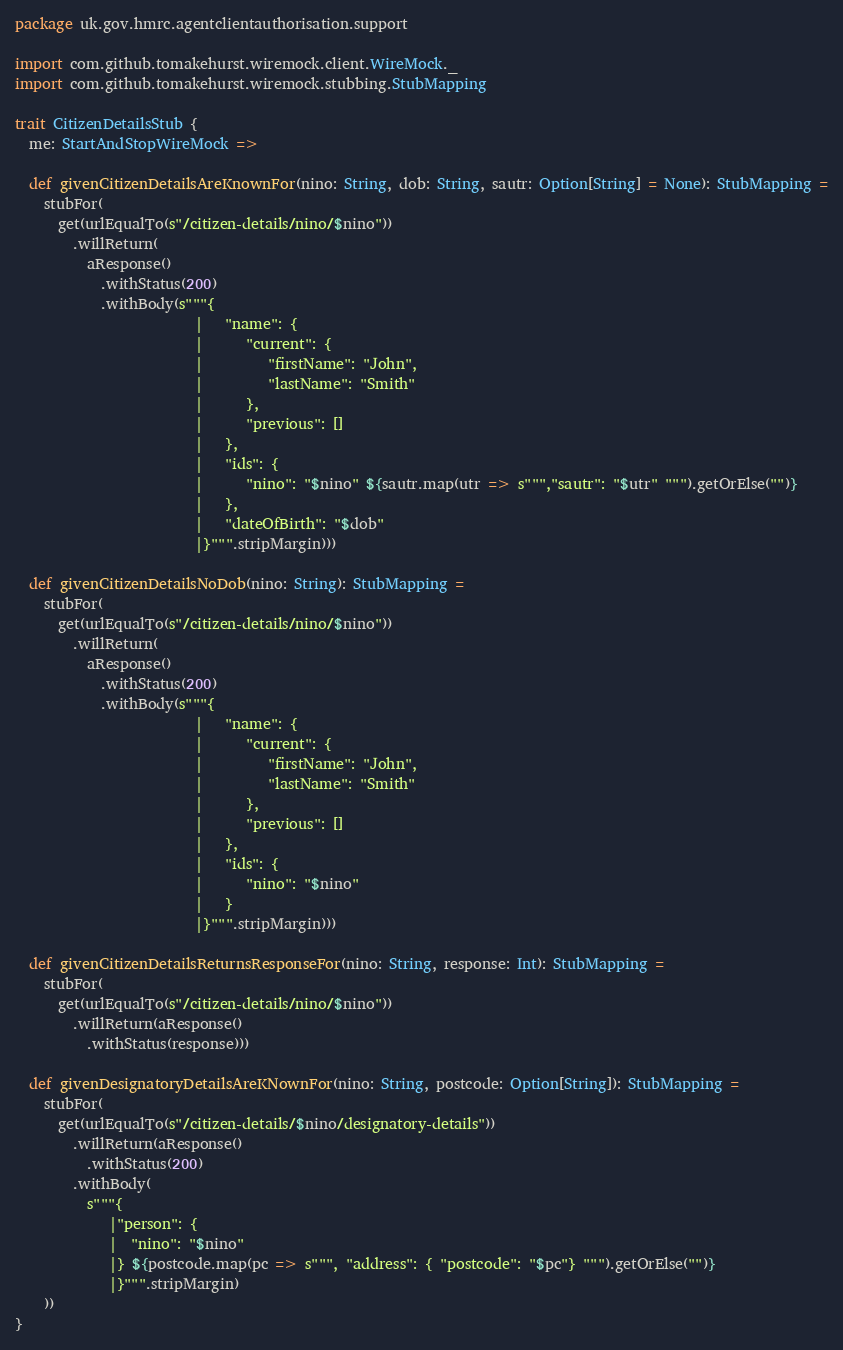<code> <loc_0><loc_0><loc_500><loc_500><_Scala_>package uk.gov.hmrc.agentclientauthorisation.support

import com.github.tomakehurst.wiremock.client.WireMock._
import com.github.tomakehurst.wiremock.stubbing.StubMapping

trait CitizenDetailsStub {
  me: StartAndStopWireMock =>

  def givenCitizenDetailsAreKnownFor(nino: String, dob: String, sautr: Option[String] = None): StubMapping =
    stubFor(
      get(urlEqualTo(s"/citizen-details/nino/$nino"))
        .willReturn(
          aResponse()
            .withStatus(200)
            .withBody(s"""{
                         |   "name": {
                         |      "current": {
                         |         "firstName": "John",
                         |         "lastName": "Smith"
                         |      },
                         |      "previous": []
                         |   },
                         |   "ids": {
                         |      "nino": "$nino" ${sautr.map(utr => s""","sautr": "$utr" """).getOrElse("")}
                         |   },
                         |   "dateOfBirth": "$dob"
                         |}""".stripMargin)))

  def givenCitizenDetailsNoDob(nino: String): StubMapping =
    stubFor(
      get(urlEqualTo(s"/citizen-details/nino/$nino"))
        .willReturn(
          aResponse()
            .withStatus(200)
            .withBody(s"""{
                         |   "name": {
                         |      "current": {
                         |         "firstName": "John",
                         |         "lastName": "Smith"
                         |      },
                         |      "previous": []
                         |   },
                         |   "ids": {
                         |      "nino": "$nino"
                         |   }
                         |}""".stripMargin)))

  def givenCitizenDetailsReturnsResponseFor(nino: String, response: Int): StubMapping =
    stubFor(
      get(urlEqualTo(s"/citizen-details/nino/$nino"))
        .willReturn(aResponse()
          .withStatus(response)))

  def givenDesignatoryDetailsAreKNownFor(nino: String, postcode: Option[String]): StubMapping =
    stubFor(
      get(urlEqualTo(s"/citizen-details/$nino/designatory-details"))
        .willReturn(aResponse()
          .withStatus(200)
        .withBody(
          s"""{
             |"person": {
             |  "nino": "$nino"
             |} ${postcode.map(pc => s""", "address": { "postcode": "$pc"} """).getOrElse("")}
             |}""".stripMargin)
    ))
}
</code> 